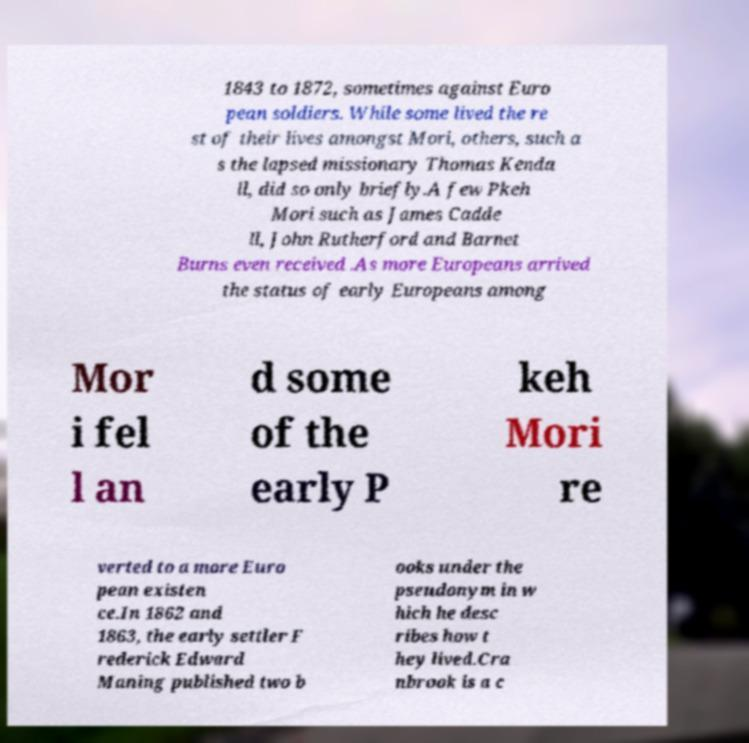Could you assist in decoding the text presented in this image and type it out clearly? 1843 to 1872, sometimes against Euro pean soldiers. While some lived the re st of their lives amongst Mori, others, such a s the lapsed missionary Thomas Kenda ll, did so only briefly.A few Pkeh Mori such as James Cadde ll, John Rutherford and Barnet Burns even received .As more Europeans arrived the status of early Europeans among Mor i fel l an d some of the early P keh Mori re verted to a more Euro pean existen ce.In 1862 and 1863, the early settler F rederick Edward Maning published two b ooks under the pseudonym in w hich he desc ribes how t hey lived.Cra nbrook is a c 